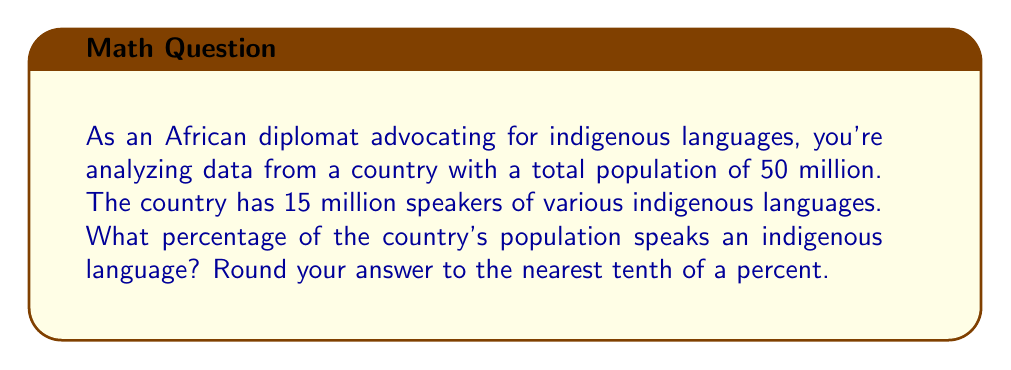What is the answer to this math problem? To solve this problem, we need to use the formula for calculating percentage:

$$ \text{Percentage} = \frac{\text{Part}}{\text{Whole}} \times 100\% $$

In this case:
- The part is the number of indigenous language speakers: 15 million
- The whole is the total population: 50 million

Let's substitute these values into the formula:

$$ \text{Percentage} = \frac{15,000,000}{50,000,000} \times 100\% $$

Simplify the fraction:

$$ \text{Percentage} = \frac{3}{10} \times 100\% $$

Perform the multiplication:

$$ \text{Percentage} = 30\% $$

Since we're asked to round to the nearest tenth of a percent, 30% is already in that form, so no further rounding is necessary.
Answer: 30.0% 